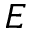Convert formula to latex. <formula><loc_0><loc_0><loc_500><loc_500>E</formula> 